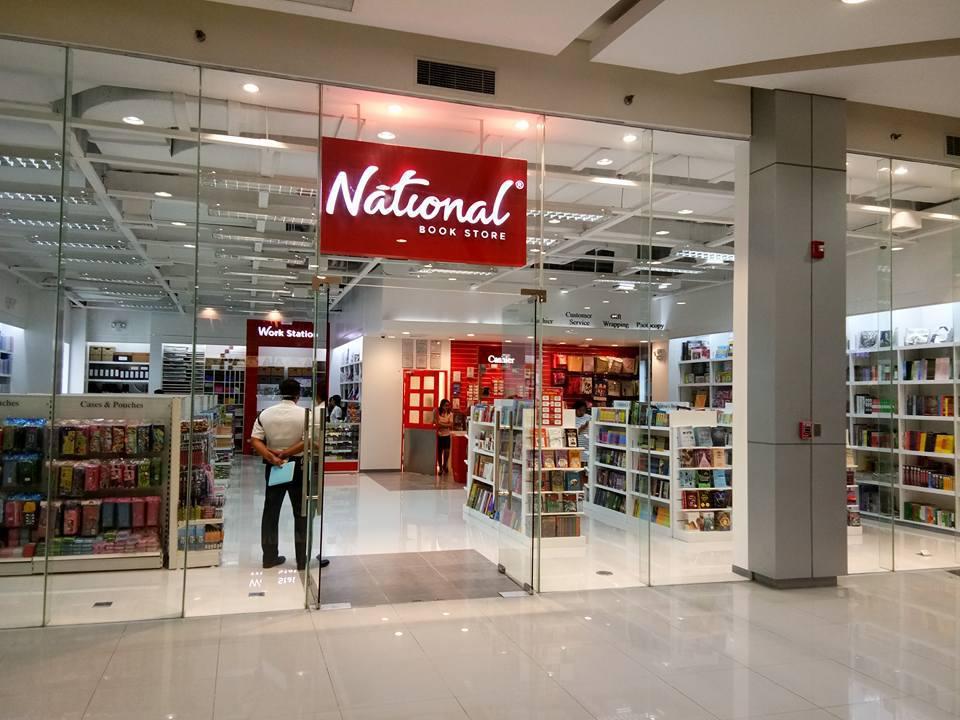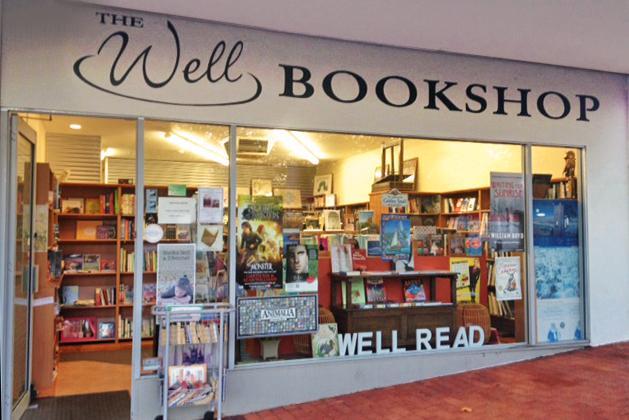The first image is the image on the left, the second image is the image on the right. Considering the images on both sides, is "An upright blue display stands outside the entry area of one of the stores." valid? Answer yes or no. No. The first image is the image on the left, the second image is the image on the right. For the images displayed, is the sentence "At least one person is standing near the entrance of the store in the image on the left." factually correct? Answer yes or no. Yes. 